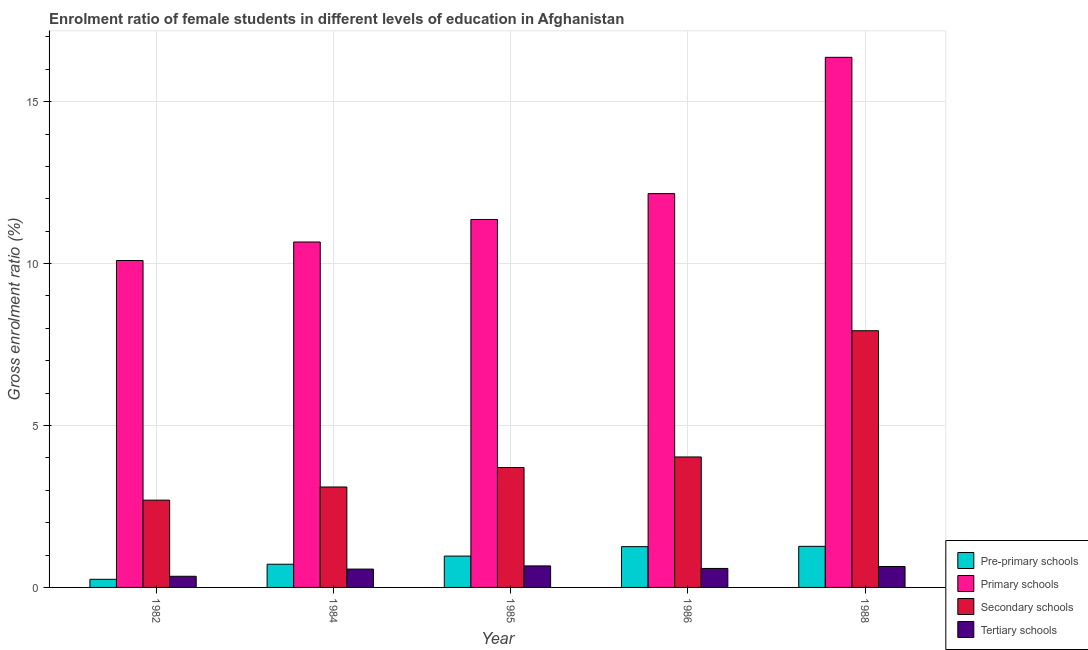How many groups of bars are there?
Offer a very short reply. 5. Are the number of bars on each tick of the X-axis equal?
Your answer should be compact. Yes. How many bars are there on the 5th tick from the left?
Keep it short and to the point. 4. In how many cases, is the number of bars for a given year not equal to the number of legend labels?
Provide a short and direct response. 0. What is the gross enrolment ratio(male) in primary schools in 1988?
Give a very brief answer. 16.37. Across all years, what is the maximum gross enrolment ratio(male) in primary schools?
Keep it short and to the point. 16.37. Across all years, what is the minimum gross enrolment ratio(male) in pre-primary schools?
Your answer should be very brief. 0.25. In which year was the gross enrolment ratio(male) in tertiary schools maximum?
Provide a succinct answer. 1985. What is the total gross enrolment ratio(male) in secondary schools in the graph?
Make the answer very short. 21.45. What is the difference between the gross enrolment ratio(male) in tertiary schools in 1984 and that in 1986?
Provide a succinct answer. -0.02. What is the difference between the gross enrolment ratio(male) in tertiary schools in 1988 and the gross enrolment ratio(male) in primary schools in 1986?
Offer a terse response. 0.06. What is the average gross enrolment ratio(male) in primary schools per year?
Offer a terse response. 12.13. In the year 1985, what is the difference between the gross enrolment ratio(male) in tertiary schools and gross enrolment ratio(male) in secondary schools?
Provide a short and direct response. 0. What is the ratio of the gross enrolment ratio(male) in primary schools in 1982 to that in 1985?
Make the answer very short. 0.89. Is the gross enrolment ratio(male) in tertiary schools in 1986 less than that in 1988?
Offer a terse response. Yes. Is the difference between the gross enrolment ratio(male) in pre-primary schools in 1984 and 1985 greater than the difference between the gross enrolment ratio(male) in secondary schools in 1984 and 1985?
Offer a very short reply. No. What is the difference between the highest and the second highest gross enrolment ratio(male) in tertiary schools?
Give a very brief answer. 0.02. What is the difference between the highest and the lowest gross enrolment ratio(male) in secondary schools?
Provide a short and direct response. 5.23. Is it the case that in every year, the sum of the gross enrolment ratio(male) in primary schools and gross enrolment ratio(male) in secondary schools is greater than the sum of gross enrolment ratio(male) in pre-primary schools and gross enrolment ratio(male) in tertiary schools?
Provide a short and direct response. Yes. What does the 3rd bar from the left in 1986 represents?
Make the answer very short. Secondary schools. What does the 4th bar from the right in 1986 represents?
Give a very brief answer. Pre-primary schools. Is it the case that in every year, the sum of the gross enrolment ratio(male) in pre-primary schools and gross enrolment ratio(male) in primary schools is greater than the gross enrolment ratio(male) in secondary schools?
Provide a succinct answer. Yes. How many bars are there?
Keep it short and to the point. 20. How many years are there in the graph?
Provide a short and direct response. 5. How are the legend labels stacked?
Give a very brief answer. Vertical. What is the title of the graph?
Provide a succinct answer. Enrolment ratio of female students in different levels of education in Afghanistan. Does "Ease of arranging shipments" appear as one of the legend labels in the graph?
Keep it short and to the point. No. What is the label or title of the X-axis?
Make the answer very short. Year. What is the Gross enrolment ratio (%) in Pre-primary schools in 1982?
Your response must be concise. 0.25. What is the Gross enrolment ratio (%) in Primary schools in 1982?
Give a very brief answer. 10.09. What is the Gross enrolment ratio (%) in Secondary schools in 1982?
Ensure brevity in your answer.  2.69. What is the Gross enrolment ratio (%) of Tertiary schools in 1982?
Your answer should be compact. 0.34. What is the Gross enrolment ratio (%) in Pre-primary schools in 1984?
Your answer should be very brief. 0.72. What is the Gross enrolment ratio (%) of Primary schools in 1984?
Keep it short and to the point. 10.67. What is the Gross enrolment ratio (%) of Secondary schools in 1984?
Your response must be concise. 3.1. What is the Gross enrolment ratio (%) of Tertiary schools in 1984?
Your answer should be very brief. 0.57. What is the Gross enrolment ratio (%) in Pre-primary schools in 1985?
Provide a succinct answer. 0.97. What is the Gross enrolment ratio (%) of Primary schools in 1985?
Make the answer very short. 11.36. What is the Gross enrolment ratio (%) in Secondary schools in 1985?
Make the answer very short. 3.7. What is the Gross enrolment ratio (%) in Tertiary schools in 1985?
Offer a terse response. 0.66. What is the Gross enrolment ratio (%) in Pre-primary schools in 1986?
Make the answer very short. 1.26. What is the Gross enrolment ratio (%) in Primary schools in 1986?
Your response must be concise. 12.16. What is the Gross enrolment ratio (%) of Secondary schools in 1986?
Keep it short and to the point. 4.03. What is the Gross enrolment ratio (%) of Tertiary schools in 1986?
Offer a terse response. 0.59. What is the Gross enrolment ratio (%) of Pre-primary schools in 1988?
Your response must be concise. 1.27. What is the Gross enrolment ratio (%) in Primary schools in 1988?
Offer a very short reply. 16.37. What is the Gross enrolment ratio (%) in Secondary schools in 1988?
Your answer should be compact. 7.93. What is the Gross enrolment ratio (%) in Tertiary schools in 1988?
Give a very brief answer. 0.65. Across all years, what is the maximum Gross enrolment ratio (%) of Pre-primary schools?
Your response must be concise. 1.27. Across all years, what is the maximum Gross enrolment ratio (%) of Primary schools?
Keep it short and to the point. 16.37. Across all years, what is the maximum Gross enrolment ratio (%) in Secondary schools?
Your response must be concise. 7.93. Across all years, what is the maximum Gross enrolment ratio (%) of Tertiary schools?
Your response must be concise. 0.66. Across all years, what is the minimum Gross enrolment ratio (%) of Pre-primary schools?
Provide a succinct answer. 0.25. Across all years, what is the minimum Gross enrolment ratio (%) of Primary schools?
Your answer should be very brief. 10.09. Across all years, what is the minimum Gross enrolment ratio (%) in Secondary schools?
Your answer should be very brief. 2.69. Across all years, what is the minimum Gross enrolment ratio (%) in Tertiary schools?
Offer a terse response. 0.34. What is the total Gross enrolment ratio (%) of Pre-primary schools in the graph?
Offer a very short reply. 4.46. What is the total Gross enrolment ratio (%) in Primary schools in the graph?
Provide a short and direct response. 60.65. What is the total Gross enrolment ratio (%) in Secondary schools in the graph?
Give a very brief answer. 21.45. What is the total Gross enrolment ratio (%) in Tertiary schools in the graph?
Your answer should be compact. 2.81. What is the difference between the Gross enrolment ratio (%) in Pre-primary schools in 1982 and that in 1984?
Provide a short and direct response. -0.47. What is the difference between the Gross enrolment ratio (%) in Primary schools in 1982 and that in 1984?
Keep it short and to the point. -0.57. What is the difference between the Gross enrolment ratio (%) of Secondary schools in 1982 and that in 1984?
Offer a terse response. -0.41. What is the difference between the Gross enrolment ratio (%) in Tertiary schools in 1982 and that in 1984?
Your answer should be very brief. -0.22. What is the difference between the Gross enrolment ratio (%) in Pre-primary schools in 1982 and that in 1985?
Ensure brevity in your answer.  -0.72. What is the difference between the Gross enrolment ratio (%) in Primary schools in 1982 and that in 1985?
Your answer should be very brief. -1.27. What is the difference between the Gross enrolment ratio (%) of Secondary schools in 1982 and that in 1985?
Ensure brevity in your answer.  -1.01. What is the difference between the Gross enrolment ratio (%) in Tertiary schools in 1982 and that in 1985?
Keep it short and to the point. -0.32. What is the difference between the Gross enrolment ratio (%) in Pre-primary schools in 1982 and that in 1986?
Your answer should be very brief. -1.01. What is the difference between the Gross enrolment ratio (%) in Primary schools in 1982 and that in 1986?
Provide a succinct answer. -2.07. What is the difference between the Gross enrolment ratio (%) in Secondary schools in 1982 and that in 1986?
Offer a very short reply. -1.33. What is the difference between the Gross enrolment ratio (%) in Tertiary schools in 1982 and that in 1986?
Offer a very short reply. -0.24. What is the difference between the Gross enrolment ratio (%) in Pre-primary schools in 1982 and that in 1988?
Your answer should be very brief. -1.02. What is the difference between the Gross enrolment ratio (%) in Primary schools in 1982 and that in 1988?
Your response must be concise. -6.27. What is the difference between the Gross enrolment ratio (%) of Secondary schools in 1982 and that in 1988?
Offer a very short reply. -5.23. What is the difference between the Gross enrolment ratio (%) of Tertiary schools in 1982 and that in 1988?
Offer a very short reply. -0.3. What is the difference between the Gross enrolment ratio (%) of Pre-primary schools in 1984 and that in 1985?
Your answer should be compact. -0.25. What is the difference between the Gross enrolment ratio (%) of Primary schools in 1984 and that in 1985?
Offer a very short reply. -0.7. What is the difference between the Gross enrolment ratio (%) in Secondary schools in 1984 and that in 1985?
Provide a short and direct response. -0.6. What is the difference between the Gross enrolment ratio (%) of Tertiary schools in 1984 and that in 1985?
Provide a succinct answer. -0.1. What is the difference between the Gross enrolment ratio (%) of Pre-primary schools in 1984 and that in 1986?
Provide a short and direct response. -0.54. What is the difference between the Gross enrolment ratio (%) of Primary schools in 1984 and that in 1986?
Offer a very short reply. -1.49. What is the difference between the Gross enrolment ratio (%) in Secondary schools in 1984 and that in 1986?
Keep it short and to the point. -0.93. What is the difference between the Gross enrolment ratio (%) of Tertiary schools in 1984 and that in 1986?
Offer a terse response. -0.02. What is the difference between the Gross enrolment ratio (%) in Pre-primary schools in 1984 and that in 1988?
Provide a succinct answer. -0.55. What is the difference between the Gross enrolment ratio (%) of Primary schools in 1984 and that in 1988?
Offer a terse response. -5.7. What is the difference between the Gross enrolment ratio (%) in Secondary schools in 1984 and that in 1988?
Keep it short and to the point. -4.83. What is the difference between the Gross enrolment ratio (%) in Tertiary schools in 1984 and that in 1988?
Offer a very short reply. -0.08. What is the difference between the Gross enrolment ratio (%) in Pre-primary schools in 1985 and that in 1986?
Give a very brief answer. -0.29. What is the difference between the Gross enrolment ratio (%) of Primary schools in 1985 and that in 1986?
Your answer should be compact. -0.8. What is the difference between the Gross enrolment ratio (%) of Secondary schools in 1985 and that in 1986?
Your answer should be compact. -0.33. What is the difference between the Gross enrolment ratio (%) of Tertiary schools in 1985 and that in 1986?
Your answer should be compact. 0.08. What is the difference between the Gross enrolment ratio (%) of Pre-primary schools in 1985 and that in 1988?
Offer a very short reply. -0.3. What is the difference between the Gross enrolment ratio (%) in Primary schools in 1985 and that in 1988?
Provide a succinct answer. -5.01. What is the difference between the Gross enrolment ratio (%) in Secondary schools in 1985 and that in 1988?
Ensure brevity in your answer.  -4.22. What is the difference between the Gross enrolment ratio (%) of Tertiary schools in 1985 and that in 1988?
Provide a succinct answer. 0.02. What is the difference between the Gross enrolment ratio (%) in Pre-primary schools in 1986 and that in 1988?
Provide a succinct answer. -0.01. What is the difference between the Gross enrolment ratio (%) in Primary schools in 1986 and that in 1988?
Provide a short and direct response. -4.21. What is the difference between the Gross enrolment ratio (%) in Secondary schools in 1986 and that in 1988?
Your answer should be very brief. -3.9. What is the difference between the Gross enrolment ratio (%) in Tertiary schools in 1986 and that in 1988?
Your response must be concise. -0.06. What is the difference between the Gross enrolment ratio (%) in Pre-primary schools in 1982 and the Gross enrolment ratio (%) in Primary schools in 1984?
Provide a succinct answer. -10.41. What is the difference between the Gross enrolment ratio (%) of Pre-primary schools in 1982 and the Gross enrolment ratio (%) of Secondary schools in 1984?
Your answer should be very brief. -2.85. What is the difference between the Gross enrolment ratio (%) in Pre-primary schools in 1982 and the Gross enrolment ratio (%) in Tertiary schools in 1984?
Offer a terse response. -0.32. What is the difference between the Gross enrolment ratio (%) in Primary schools in 1982 and the Gross enrolment ratio (%) in Secondary schools in 1984?
Offer a terse response. 6.99. What is the difference between the Gross enrolment ratio (%) in Primary schools in 1982 and the Gross enrolment ratio (%) in Tertiary schools in 1984?
Provide a short and direct response. 9.53. What is the difference between the Gross enrolment ratio (%) in Secondary schools in 1982 and the Gross enrolment ratio (%) in Tertiary schools in 1984?
Offer a terse response. 2.13. What is the difference between the Gross enrolment ratio (%) of Pre-primary schools in 1982 and the Gross enrolment ratio (%) of Primary schools in 1985?
Make the answer very short. -11.11. What is the difference between the Gross enrolment ratio (%) in Pre-primary schools in 1982 and the Gross enrolment ratio (%) in Secondary schools in 1985?
Your response must be concise. -3.45. What is the difference between the Gross enrolment ratio (%) of Pre-primary schools in 1982 and the Gross enrolment ratio (%) of Tertiary schools in 1985?
Ensure brevity in your answer.  -0.41. What is the difference between the Gross enrolment ratio (%) in Primary schools in 1982 and the Gross enrolment ratio (%) in Secondary schools in 1985?
Provide a succinct answer. 6.39. What is the difference between the Gross enrolment ratio (%) in Primary schools in 1982 and the Gross enrolment ratio (%) in Tertiary schools in 1985?
Keep it short and to the point. 9.43. What is the difference between the Gross enrolment ratio (%) of Secondary schools in 1982 and the Gross enrolment ratio (%) of Tertiary schools in 1985?
Offer a very short reply. 2.03. What is the difference between the Gross enrolment ratio (%) in Pre-primary schools in 1982 and the Gross enrolment ratio (%) in Primary schools in 1986?
Ensure brevity in your answer.  -11.91. What is the difference between the Gross enrolment ratio (%) in Pre-primary schools in 1982 and the Gross enrolment ratio (%) in Secondary schools in 1986?
Provide a succinct answer. -3.78. What is the difference between the Gross enrolment ratio (%) in Pre-primary schools in 1982 and the Gross enrolment ratio (%) in Tertiary schools in 1986?
Provide a short and direct response. -0.34. What is the difference between the Gross enrolment ratio (%) in Primary schools in 1982 and the Gross enrolment ratio (%) in Secondary schools in 1986?
Give a very brief answer. 6.07. What is the difference between the Gross enrolment ratio (%) in Primary schools in 1982 and the Gross enrolment ratio (%) in Tertiary schools in 1986?
Ensure brevity in your answer.  9.51. What is the difference between the Gross enrolment ratio (%) of Secondary schools in 1982 and the Gross enrolment ratio (%) of Tertiary schools in 1986?
Provide a succinct answer. 2.11. What is the difference between the Gross enrolment ratio (%) of Pre-primary schools in 1982 and the Gross enrolment ratio (%) of Primary schools in 1988?
Provide a short and direct response. -16.12. What is the difference between the Gross enrolment ratio (%) in Pre-primary schools in 1982 and the Gross enrolment ratio (%) in Secondary schools in 1988?
Offer a terse response. -7.68. What is the difference between the Gross enrolment ratio (%) in Pre-primary schools in 1982 and the Gross enrolment ratio (%) in Tertiary schools in 1988?
Provide a succinct answer. -0.4. What is the difference between the Gross enrolment ratio (%) in Primary schools in 1982 and the Gross enrolment ratio (%) in Secondary schools in 1988?
Ensure brevity in your answer.  2.17. What is the difference between the Gross enrolment ratio (%) of Primary schools in 1982 and the Gross enrolment ratio (%) of Tertiary schools in 1988?
Ensure brevity in your answer.  9.45. What is the difference between the Gross enrolment ratio (%) of Secondary schools in 1982 and the Gross enrolment ratio (%) of Tertiary schools in 1988?
Provide a short and direct response. 2.05. What is the difference between the Gross enrolment ratio (%) of Pre-primary schools in 1984 and the Gross enrolment ratio (%) of Primary schools in 1985?
Give a very brief answer. -10.64. What is the difference between the Gross enrolment ratio (%) of Pre-primary schools in 1984 and the Gross enrolment ratio (%) of Secondary schools in 1985?
Provide a succinct answer. -2.99. What is the difference between the Gross enrolment ratio (%) of Pre-primary schools in 1984 and the Gross enrolment ratio (%) of Tertiary schools in 1985?
Keep it short and to the point. 0.05. What is the difference between the Gross enrolment ratio (%) in Primary schools in 1984 and the Gross enrolment ratio (%) in Secondary schools in 1985?
Your response must be concise. 6.96. What is the difference between the Gross enrolment ratio (%) in Primary schools in 1984 and the Gross enrolment ratio (%) in Tertiary schools in 1985?
Your answer should be compact. 10. What is the difference between the Gross enrolment ratio (%) of Secondary schools in 1984 and the Gross enrolment ratio (%) of Tertiary schools in 1985?
Provide a succinct answer. 2.44. What is the difference between the Gross enrolment ratio (%) in Pre-primary schools in 1984 and the Gross enrolment ratio (%) in Primary schools in 1986?
Your answer should be very brief. -11.44. What is the difference between the Gross enrolment ratio (%) of Pre-primary schools in 1984 and the Gross enrolment ratio (%) of Secondary schools in 1986?
Make the answer very short. -3.31. What is the difference between the Gross enrolment ratio (%) in Pre-primary schools in 1984 and the Gross enrolment ratio (%) in Tertiary schools in 1986?
Your response must be concise. 0.13. What is the difference between the Gross enrolment ratio (%) in Primary schools in 1984 and the Gross enrolment ratio (%) in Secondary schools in 1986?
Your answer should be very brief. 6.64. What is the difference between the Gross enrolment ratio (%) of Primary schools in 1984 and the Gross enrolment ratio (%) of Tertiary schools in 1986?
Offer a terse response. 10.08. What is the difference between the Gross enrolment ratio (%) of Secondary schools in 1984 and the Gross enrolment ratio (%) of Tertiary schools in 1986?
Keep it short and to the point. 2.51. What is the difference between the Gross enrolment ratio (%) in Pre-primary schools in 1984 and the Gross enrolment ratio (%) in Primary schools in 1988?
Keep it short and to the point. -15.65. What is the difference between the Gross enrolment ratio (%) of Pre-primary schools in 1984 and the Gross enrolment ratio (%) of Secondary schools in 1988?
Ensure brevity in your answer.  -7.21. What is the difference between the Gross enrolment ratio (%) of Pre-primary schools in 1984 and the Gross enrolment ratio (%) of Tertiary schools in 1988?
Offer a very short reply. 0.07. What is the difference between the Gross enrolment ratio (%) in Primary schools in 1984 and the Gross enrolment ratio (%) in Secondary schools in 1988?
Your answer should be very brief. 2.74. What is the difference between the Gross enrolment ratio (%) of Primary schools in 1984 and the Gross enrolment ratio (%) of Tertiary schools in 1988?
Your response must be concise. 10.02. What is the difference between the Gross enrolment ratio (%) in Secondary schools in 1984 and the Gross enrolment ratio (%) in Tertiary schools in 1988?
Your answer should be compact. 2.45. What is the difference between the Gross enrolment ratio (%) in Pre-primary schools in 1985 and the Gross enrolment ratio (%) in Primary schools in 1986?
Offer a very short reply. -11.19. What is the difference between the Gross enrolment ratio (%) in Pre-primary schools in 1985 and the Gross enrolment ratio (%) in Secondary schools in 1986?
Offer a very short reply. -3.06. What is the difference between the Gross enrolment ratio (%) in Pre-primary schools in 1985 and the Gross enrolment ratio (%) in Tertiary schools in 1986?
Your response must be concise. 0.38. What is the difference between the Gross enrolment ratio (%) in Primary schools in 1985 and the Gross enrolment ratio (%) in Secondary schools in 1986?
Make the answer very short. 7.33. What is the difference between the Gross enrolment ratio (%) in Primary schools in 1985 and the Gross enrolment ratio (%) in Tertiary schools in 1986?
Ensure brevity in your answer.  10.77. What is the difference between the Gross enrolment ratio (%) in Secondary schools in 1985 and the Gross enrolment ratio (%) in Tertiary schools in 1986?
Offer a terse response. 3.12. What is the difference between the Gross enrolment ratio (%) in Pre-primary schools in 1985 and the Gross enrolment ratio (%) in Primary schools in 1988?
Offer a very short reply. -15.4. What is the difference between the Gross enrolment ratio (%) in Pre-primary schools in 1985 and the Gross enrolment ratio (%) in Secondary schools in 1988?
Keep it short and to the point. -6.96. What is the difference between the Gross enrolment ratio (%) of Pre-primary schools in 1985 and the Gross enrolment ratio (%) of Tertiary schools in 1988?
Make the answer very short. 0.32. What is the difference between the Gross enrolment ratio (%) of Primary schools in 1985 and the Gross enrolment ratio (%) of Secondary schools in 1988?
Your answer should be compact. 3.43. What is the difference between the Gross enrolment ratio (%) in Primary schools in 1985 and the Gross enrolment ratio (%) in Tertiary schools in 1988?
Make the answer very short. 10.71. What is the difference between the Gross enrolment ratio (%) of Secondary schools in 1985 and the Gross enrolment ratio (%) of Tertiary schools in 1988?
Give a very brief answer. 3.06. What is the difference between the Gross enrolment ratio (%) of Pre-primary schools in 1986 and the Gross enrolment ratio (%) of Primary schools in 1988?
Make the answer very short. -15.11. What is the difference between the Gross enrolment ratio (%) in Pre-primary schools in 1986 and the Gross enrolment ratio (%) in Secondary schools in 1988?
Provide a succinct answer. -6.67. What is the difference between the Gross enrolment ratio (%) in Pre-primary schools in 1986 and the Gross enrolment ratio (%) in Tertiary schools in 1988?
Offer a very short reply. 0.61. What is the difference between the Gross enrolment ratio (%) in Primary schools in 1986 and the Gross enrolment ratio (%) in Secondary schools in 1988?
Give a very brief answer. 4.23. What is the difference between the Gross enrolment ratio (%) in Primary schools in 1986 and the Gross enrolment ratio (%) in Tertiary schools in 1988?
Ensure brevity in your answer.  11.51. What is the difference between the Gross enrolment ratio (%) in Secondary schools in 1986 and the Gross enrolment ratio (%) in Tertiary schools in 1988?
Make the answer very short. 3.38. What is the average Gross enrolment ratio (%) of Pre-primary schools per year?
Your answer should be compact. 0.89. What is the average Gross enrolment ratio (%) of Primary schools per year?
Ensure brevity in your answer.  12.13. What is the average Gross enrolment ratio (%) of Secondary schools per year?
Provide a succinct answer. 4.29. What is the average Gross enrolment ratio (%) in Tertiary schools per year?
Provide a succinct answer. 0.56. In the year 1982, what is the difference between the Gross enrolment ratio (%) in Pre-primary schools and Gross enrolment ratio (%) in Primary schools?
Give a very brief answer. -9.84. In the year 1982, what is the difference between the Gross enrolment ratio (%) in Pre-primary schools and Gross enrolment ratio (%) in Secondary schools?
Your answer should be very brief. -2.44. In the year 1982, what is the difference between the Gross enrolment ratio (%) of Pre-primary schools and Gross enrolment ratio (%) of Tertiary schools?
Provide a succinct answer. -0.09. In the year 1982, what is the difference between the Gross enrolment ratio (%) of Primary schools and Gross enrolment ratio (%) of Secondary schools?
Provide a succinct answer. 7.4. In the year 1982, what is the difference between the Gross enrolment ratio (%) of Primary schools and Gross enrolment ratio (%) of Tertiary schools?
Your response must be concise. 9.75. In the year 1982, what is the difference between the Gross enrolment ratio (%) of Secondary schools and Gross enrolment ratio (%) of Tertiary schools?
Ensure brevity in your answer.  2.35. In the year 1984, what is the difference between the Gross enrolment ratio (%) of Pre-primary schools and Gross enrolment ratio (%) of Primary schools?
Give a very brief answer. -9.95. In the year 1984, what is the difference between the Gross enrolment ratio (%) in Pre-primary schools and Gross enrolment ratio (%) in Secondary schools?
Your answer should be very brief. -2.38. In the year 1984, what is the difference between the Gross enrolment ratio (%) of Pre-primary schools and Gross enrolment ratio (%) of Tertiary schools?
Offer a terse response. 0.15. In the year 1984, what is the difference between the Gross enrolment ratio (%) of Primary schools and Gross enrolment ratio (%) of Secondary schools?
Give a very brief answer. 7.56. In the year 1984, what is the difference between the Gross enrolment ratio (%) of Primary schools and Gross enrolment ratio (%) of Tertiary schools?
Give a very brief answer. 10.1. In the year 1984, what is the difference between the Gross enrolment ratio (%) in Secondary schools and Gross enrolment ratio (%) in Tertiary schools?
Your response must be concise. 2.53. In the year 1985, what is the difference between the Gross enrolment ratio (%) in Pre-primary schools and Gross enrolment ratio (%) in Primary schools?
Provide a short and direct response. -10.39. In the year 1985, what is the difference between the Gross enrolment ratio (%) of Pre-primary schools and Gross enrolment ratio (%) of Secondary schools?
Provide a succinct answer. -2.73. In the year 1985, what is the difference between the Gross enrolment ratio (%) in Pre-primary schools and Gross enrolment ratio (%) in Tertiary schools?
Your response must be concise. 0.3. In the year 1985, what is the difference between the Gross enrolment ratio (%) of Primary schools and Gross enrolment ratio (%) of Secondary schools?
Make the answer very short. 7.66. In the year 1985, what is the difference between the Gross enrolment ratio (%) of Primary schools and Gross enrolment ratio (%) of Tertiary schools?
Provide a succinct answer. 10.7. In the year 1985, what is the difference between the Gross enrolment ratio (%) of Secondary schools and Gross enrolment ratio (%) of Tertiary schools?
Offer a very short reply. 3.04. In the year 1986, what is the difference between the Gross enrolment ratio (%) of Pre-primary schools and Gross enrolment ratio (%) of Primary schools?
Offer a very short reply. -10.9. In the year 1986, what is the difference between the Gross enrolment ratio (%) in Pre-primary schools and Gross enrolment ratio (%) in Secondary schools?
Make the answer very short. -2.77. In the year 1986, what is the difference between the Gross enrolment ratio (%) of Pre-primary schools and Gross enrolment ratio (%) of Tertiary schools?
Your response must be concise. 0.67. In the year 1986, what is the difference between the Gross enrolment ratio (%) in Primary schools and Gross enrolment ratio (%) in Secondary schools?
Offer a very short reply. 8.13. In the year 1986, what is the difference between the Gross enrolment ratio (%) of Primary schools and Gross enrolment ratio (%) of Tertiary schools?
Provide a short and direct response. 11.57. In the year 1986, what is the difference between the Gross enrolment ratio (%) in Secondary schools and Gross enrolment ratio (%) in Tertiary schools?
Ensure brevity in your answer.  3.44. In the year 1988, what is the difference between the Gross enrolment ratio (%) in Pre-primary schools and Gross enrolment ratio (%) in Primary schools?
Your answer should be very brief. -15.1. In the year 1988, what is the difference between the Gross enrolment ratio (%) in Pre-primary schools and Gross enrolment ratio (%) in Secondary schools?
Provide a succinct answer. -6.66. In the year 1988, what is the difference between the Gross enrolment ratio (%) of Pre-primary schools and Gross enrolment ratio (%) of Tertiary schools?
Your answer should be compact. 0.62. In the year 1988, what is the difference between the Gross enrolment ratio (%) in Primary schools and Gross enrolment ratio (%) in Secondary schools?
Offer a terse response. 8.44. In the year 1988, what is the difference between the Gross enrolment ratio (%) in Primary schools and Gross enrolment ratio (%) in Tertiary schools?
Ensure brevity in your answer.  15.72. In the year 1988, what is the difference between the Gross enrolment ratio (%) of Secondary schools and Gross enrolment ratio (%) of Tertiary schools?
Offer a very short reply. 7.28. What is the ratio of the Gross enrolment ratio (%) in Pre-primary schools in 1982 to that in 1984?
Give a very brief answer. 0.35. What is the ratio of the Gross enrolment ratio (%) in Primary schools in 1982 to that in 1984?
Provide a short and direct response. 0.95. What is the ratio of the Gross enrolment ratio (%) in Secondary schools in 1982 to that in 1984?
Ensure brevity in your answer.  0.87. What is the ratio of the Gross enrolment ratio (%) in Tertiary schools in 1982 to that in 1984?
Your answer should be compact. 0.61. What is the ratio of the Gross enrolment ratio (%) in Pre-primary schools in 1982 to that in 1985?
Your answer should be very brief. 0.26. What is the ratio of the Gross enrolment ratio (%) of Primary schools in 1982 to that in 1985?
Offer a very short reply. 0.89. What is the ratio of the Gross enrolment ratio (%) in Secondary schools in 1982 to that in 1985?
Give a very brief answer. 0.73. What is the ratio of the Gross enrolment ratio (%) of Tertiary schools in 1982 to that in 1985?
Give a very brief answer. 0.52. What is the ratio of the Gross enrolment ratio (%) in Pre-primary schools in 1982 to that in 1986?
Give a very brief answer. 0.2. What is the ratio of the Gross enrolment ratio (%) in Primary schools in 1982 to that in 1986?
Make the answer very short. 0.83. What is the ratio of the Gross enrolment ratio (%) in Secondary schools in 1982 to that in 1986?
Your response must be concise. 0.67. What is the ratio of the Gross enrolment ratio (%) in Tertiary schools in 1982 to that in 1986?
Provide a succinct answer. 0.59. What is the ratio of the Gross enrolment ratio (%) in Pre-primary schools in 1982 to that in 1988?
Make the answer very short. 0.2. What is the ratio of the Gross enrolment ratio (%) of Primary schools in 1982 to that in 1988?
Provide a short and direct response. 0.62. What is the ratio of the Gross enrolment ratio (%) of Secondary schools in 1982 to that in 1988?
Provide a short and direct response. 0.34. What is the ratio of the Gross enrolment ratio (%) in Tertiary schools in 1982 to that in 1988?
Your answer should be compact. 0.53. What is the ratio of the Gross enrolment ratio (%) of Pre-primary schools in 1984 to that in 1985?
Make the answer very short. 0.74. What is the ratio of the Gross enrolment ratio (%) in Primary schools in 1984 to that in 1985?
Offer a terse response. 0.94. What is the ratio of the Gross enrolment ratio (%) in Secondary schools in 1984 to that in 1985?
Offer a very short reply. 0.84. What is the ratio of the Gross enrolment ratio (%) in Tertiary schools in 1984 to that in 1985?
Offer a terse response. 0.85. What is the ratio of the Gross enrolment ratio (%) of Pre-primary schools in 1984 to that in 1986?
Provide a short and direct response. 0.57. What is the ratio of the Gross enrolment ratio (%) of Primary schools in 1984 to that in 1986?
Provide a short and direct response. 0.88. What is the ratio of the Gross enrolment ratio (%) of Secondary schools in 1984 to that in 1986?
Your answer should be very brief. 0.77. What is the ratio of the Gross enrolment ratio (%) in Tertiary schools in 1984 to that in 1986?
Keep it short and to the point. 0.97. What is the ratio of the Gross enrolment ratio (%) in Pre-primary schools in 1984 to that in 1988?
Provide a short and direct response. 0.56. What is the ratio of the Gross enrolment ratio (%) of Primary schools in 1984 to that in 1988?
Ensure brevity in your answer.  0.65. What is the ratio of the Gross enrolment ratio (%) of Secondary schools in 1984 to that in 1988?
Provide a short and direct response. 0.39. What is the ratio of the Gross enrolment ratio (%) in Tertiary schools in 1984 to that in 1988?
Your answer should be very brief. 0.88. What is the ratio of the Gross enrolment ratio (%) in Pre-primary schools in 1985 to that in 1986?
Your answer should be very brief. 0.77. What is the ratio of the Gross enrolment ratio (%) of Primary schools in 1985 to that in 1986?
Give a very brief answer. 0.93. What is the ratio of the Gross enrolment ratio (%) of Secondary schools in 1985 to that in 1986?
Your answer should be compact. 0.92. What is the ratio of the Gross enrolment ratio (%) in Tertiary schools in 1985 to that in 1986?
Your response must be concise. 1.13. What is the ratio of the Gross enrolment ratio (%) in Pre-primary schools in 1985 to that in 1988?
Your answer should be compact. 0.76. What is the ratio of the Gross enrolment ratio (%) of Primary schools in 1985 to that in 1988?
Your answer should be compact. 0.69. What is the ratio of the Gross enrolment ratio (%) of Secondary schools in 1985 to that in 1988?
Your answer should be very brief. 0.47. What is the ratio of the Gross enrolment ratio (%) in Tertiary schools in 1985 to that in 1988?
Offer a very short reply. 1.03. What is the ratio of the Gross enrolment ratio (%) of Pre-primary schools in 1986 to that in 1988?
Ensure brevity in your answer.  0.99. What is the ratio of the Gross enrolment ratio (%) in Primary schools in 1986 to that in 1988?
Your response must be concise. 0.74. What is the ratio of the Gross enrolment ratio (%) of Secondary schools in 1986 to that in 1988?
Ensure brevity in your answer.  0.51. What is the ratio of the Gross enrolment ratio (%) of Tertiary schools in 1986 to that in 1988?
Your answer should be very brief. 0.91. What is the difference between the highest and the second highest Gross enrolment ratio (%) in Pre-primary schools?
Offer a terse response. 0.01. What is the difference between the highest and the second highest Gross enrolment ratio (%) of Primary schools?
Your answer should be compact. 4.21. What is the difference between the highest and the second highest Gross enrolment ratio (%) in Secondary schools?
Your answer should be very brief. 3.9. What is the difference between the highest and the second highest Gross enrolment ratio (%) of Tertiary schools?
Keep it short and to the point. 0.02. What is the difference between the highest and the lowest Gross enrolment ratio (%) of Pre-primary schools?
Your answer should be compact. 1.02. What is the difference between the highest and the lowest Gross enrolment ratio (%) of Primary schools?
Your answer should be very brief. 6.27. What is the difference between the highest and the lowest Gross enrolment ratio (%) in Secondary schools?
Provide a succinct answer. 5.23. What is the difference between the highest and the lowest Gross enrolment ratio (%) in Tertiary schools?
Your answer should be very brief. 0.32. 